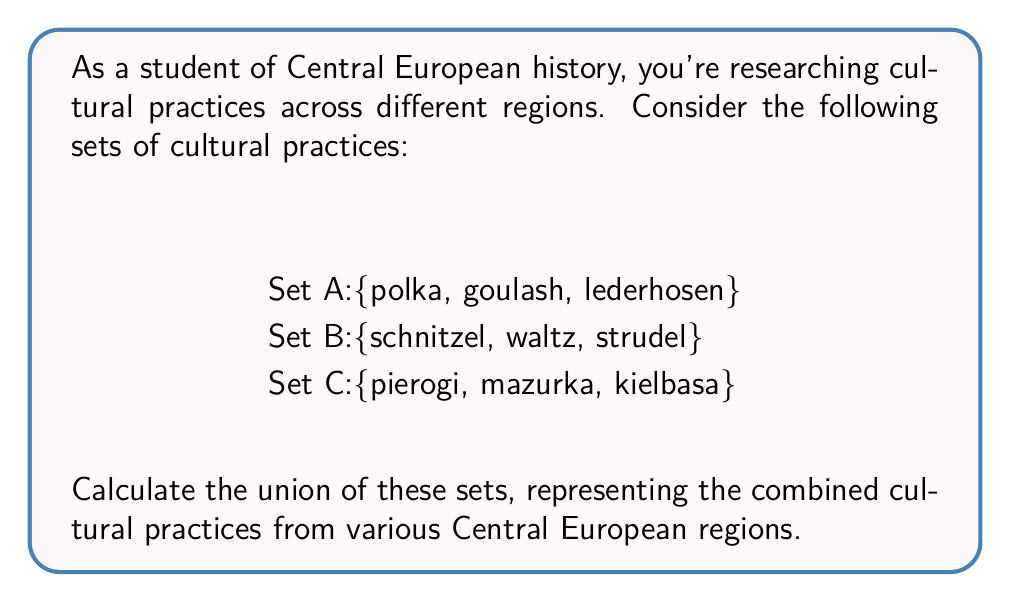What is the answer to this math problem? To calculate the union of sets A, B, and C, we need to combine all unique elements from each set. Let's approach this step-by-step:

1. Start with Set A: {polka, goulash, lederhosen}

2. Add unique elements from Set B:
   - "schnitzel", "waltz", and "strudel" are not in A, so we add them
   $A \cup B = \{polka, goulash, lederhosen, schnitzel, waltz, strudel\}$

3. Finally, add unique elements from Set C:
   - "pierogi", "mazurka", and "kielbasa" are not in $A \cup B$, so we add them

4. The final union is:
   $A \cup B \cup C = \{polka, goulash, lederhosen, schnitzel, waltz, strudel, pierogi, mazurka, kielbasa\}$

This union represents all unique cultural practices from the given Central European regions, combining elements from Austrian, Hungarian, German, and Polish cultures.
Answer: $\{polka, goulash, lederhosen, schnitzel, waltz, strudel, pierogi, mazurka, kielbasa\}$ 